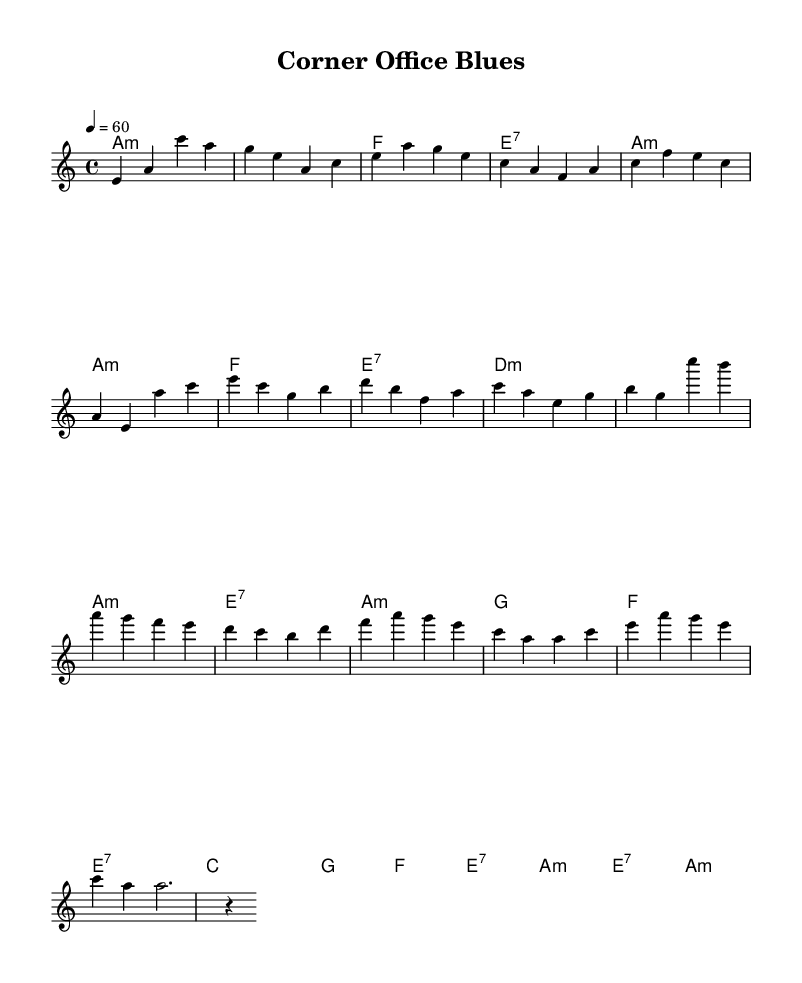What is the key signature of this music? The key signature is represented by the music notation at the beginning of the sheet, which shows one flat (B) and indicates that the piece is in a minor key. Since the music is labeled with "a minor," the key signature confirms this.
Answer: A minor What is the time signature of this music? The time signature is shown at the beginning of the sheet music, which is indicated as 4/4, meaning there are four beats per measure and a quarter note receives one beat.
Answer: 4/4 What is the tempo marking for this piece? The tempo is indicated at the beginning of the music score, which shows "4 = 60," meaning the piece should be played at a speed of 60 beats per minute.
Answer: 60 How many measures are in the chorus section? To determine the number of measures in the chorus, we look at the section labeled "Chorus" in the melody and tally the individual measures. There are four distinct measures in this section.
Answer: 4 What chords are used in the bridge? By analyzing the chord symbols written above the corresponding melody notes during the bridge section, we can identify the chords. The bridge has four chords: C, G, F, and E7.
Answer: C, G, F, E7 What is the chord progression of the verse? The chord progression can be derived by looking at the chords assigned for each measure in the verse section. The progression is A minor, A minor, F, E7, D minor, D minor, A minor, and E7.
Answer: A minor, A minor, F, E7, D minor, D minor, A minor, E7 What musical style does this piece reflect? The overall characteristics of the melody, chord choices, and the lyrical themes suggest that this piece embodies the elements of Blues music, particularly soulful ballads.
Answer: Blues 